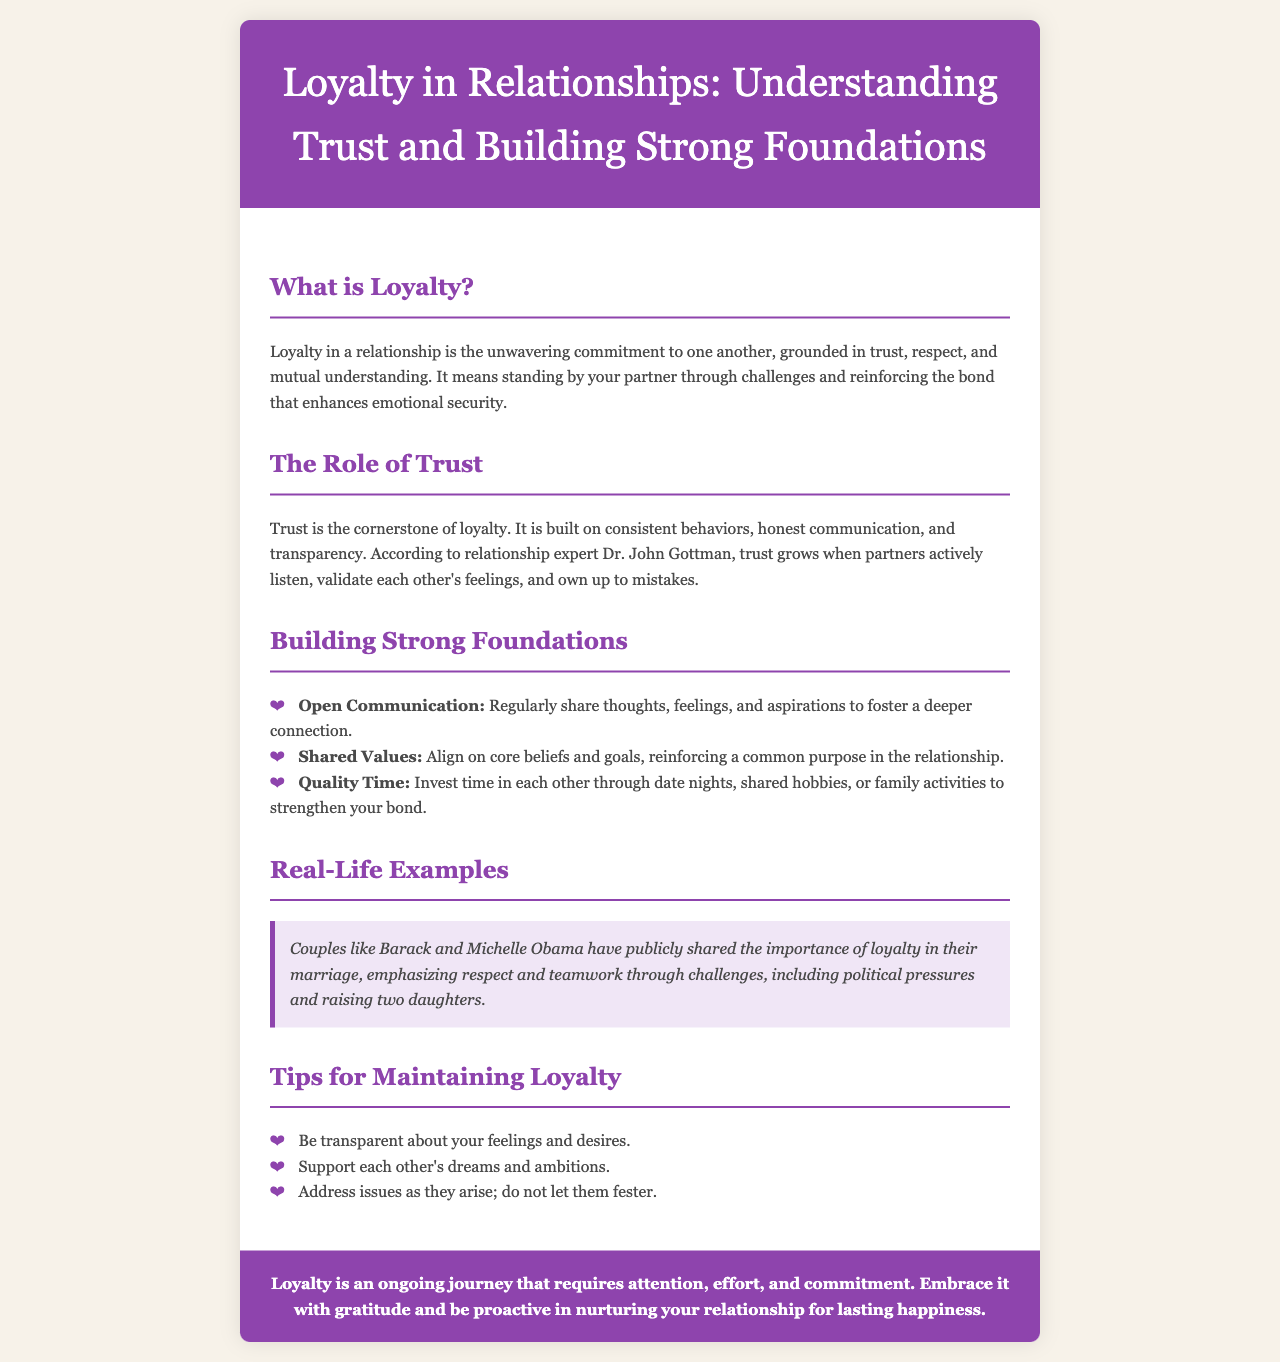What is the title of the brochure? The title is stated at the top of the document, summarizing the theme of loyalty in relationships.
Answer: Loyalty in Relationships: Understanding Trust and Building Strong Foundations What is loyalty in a relationship? The definition provided in the document explains the essence of loyalty and its components.
Answer: Unwavering commitment What builds trust in a relationship? The document outlines the key behaviors and practices that contribute to trust.
Answer: Consistent behaviors What is one of the tips for maintaining loyalty? The tips listed can be retrieved directly from the document, providing actionable advice.
Answer: Be transparent about your feelings Who is mentioned as an example of loyalty in marriage? The document gives a real-life example of a couple known for their loyalty, making them notable in this context.
Answer: Barack and Michelle Obama What role does communication play in building strong foundations? The content details the significance of different processes in enhancing relationships.
Answer: Open Communication How many tips for maintaining loyalty are mentioned? The document lists a specific number of tips, which can be counted easily.
Answer: Three tips What color is used for the header background? The document describes the visual details, including color choices for different elements.
Answer: Purple What does the conclusion emphasize about loyalty? The conclusion summarizes the overarching theme of the document, highlighting its importance.
Answer: Ongoing journey 